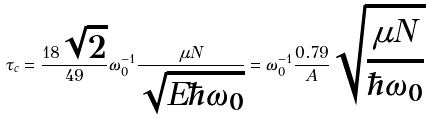<formula> <loc_0><loc_0><loc_500><loc_500>\tau _ { c } = \frac { 1 8 \sqrt { 2 } } { 4 9 } \omega _ { 0 } ^ { - 1 } \frac { \mu N } { \sqrt { E \hbar { \omega } _ { 0 } } } = \omega _ { 0 } ^ { - 1 } \frac { 0 . 7 9 } { A } \sqrt { \frac { \mu N } { \hbar { \omega } _ { 0 } } }</formula> 